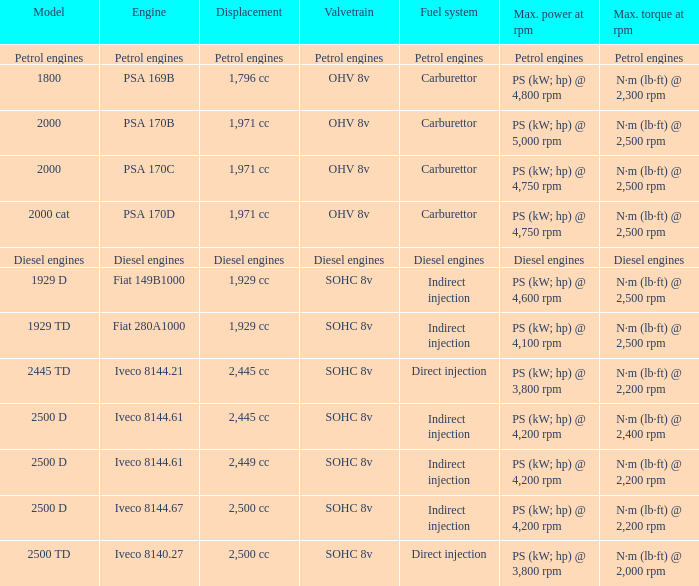What Valvetrain has a fuel system made up of petrol engines? Petrol engines. 